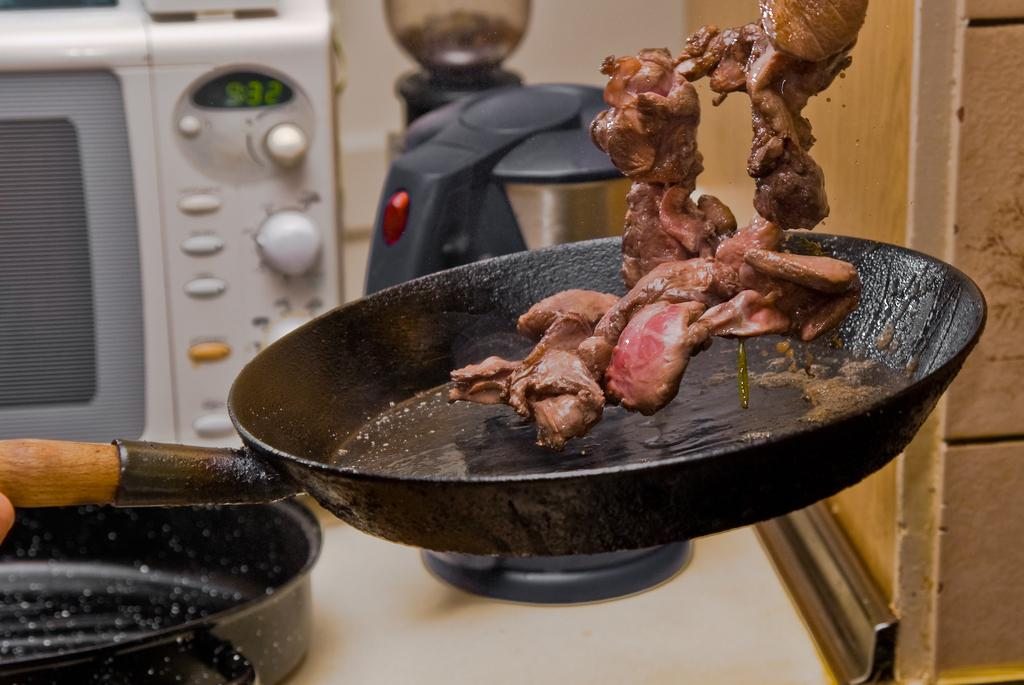What is happening with the meat in the image? The meat is being tossed up from a pan in the image. What other kitchen appliance can be seen behind the pan? There is a kettle behind the pan. What type of oven is present in the image? There is a microwave oven in the image. What is on the table in the image? There is a tray on a table in the image. What type of wall is beside the kettle? There is a wooden wall beside the kettle. Can you see a mountain in the image? No, there is no mountain present in the image. What type of bean is being cooked in the pan with the meat? There is no bean present in the image; only meat is being tossed up from the pan. 